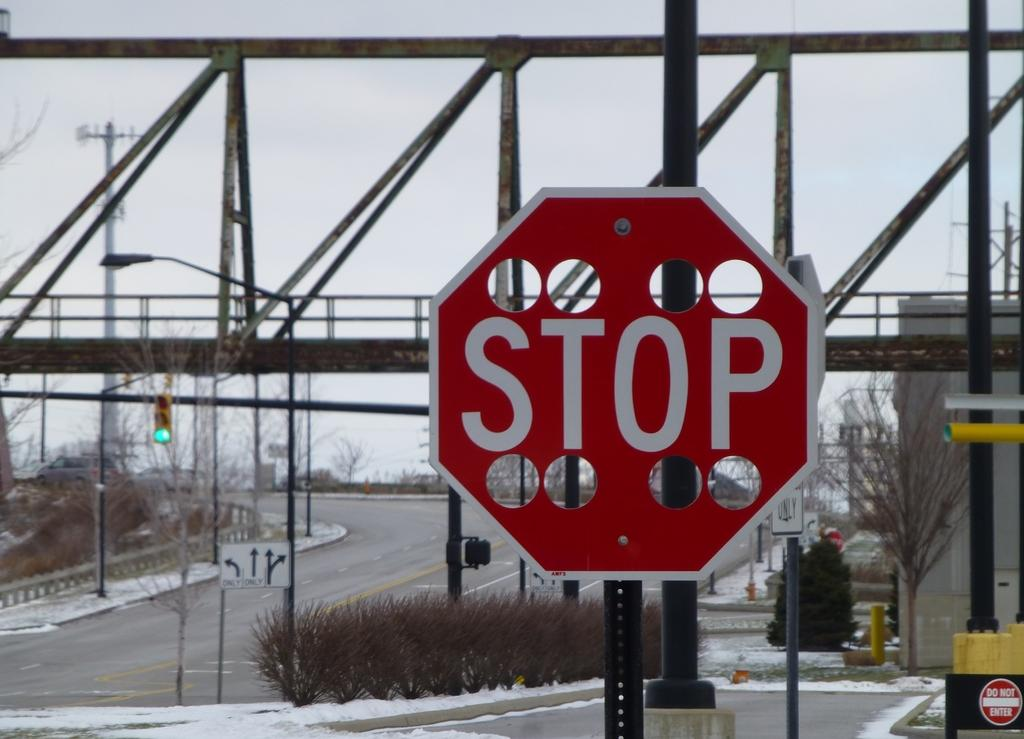<image>
Describe the image concisely. A stop sign in front of a railroad bridge has 8 large holes carved out on the top and bottom. 